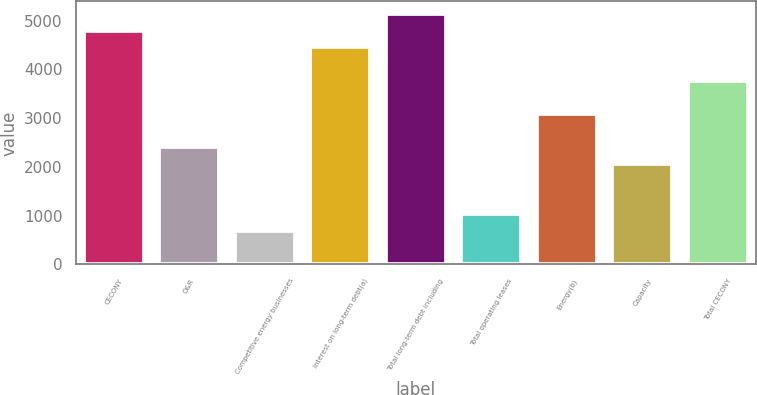Convert chart to OTSL. <chart><loc_0><loc_0><loc_500><loc_500><bar_chart><fcel>CECONY<fcel>O&R<fcel>Competitive energy businesses<fcel>Interest on long-term debt(a)<fcel>Total long-term debt including<fcel>Total operating leases<fcel>Energy(b)<fcel>Capacity<fcel>Total CECONY<nl><fcel>4794.2<fcel>2398.1<fcel>686.6<fcel>4451.9<fcel>5136.5<fcel>1028.9<fcel>3082.7<fcel>2055.8<fcel>3767.3<nl></chart> 